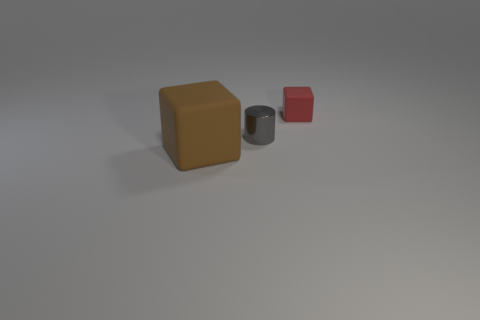Add 1 brown things. How many objects exist? 4 Subtract all gray cubes. Subtract all cyan spheres. How many cubes are left? 2 Subtract all cubes. How many objects are left? 1 Subtract all gray cylinders. Subtract all large brown blocks. How many objects are left? 1 Add 3 big brown rubber objects. How many big brown rubber objects are left? 4 Add 3 small brown objects. How many small brown objects exist? 3 Subtract 1 brown blocks. How many objects are left? 2 